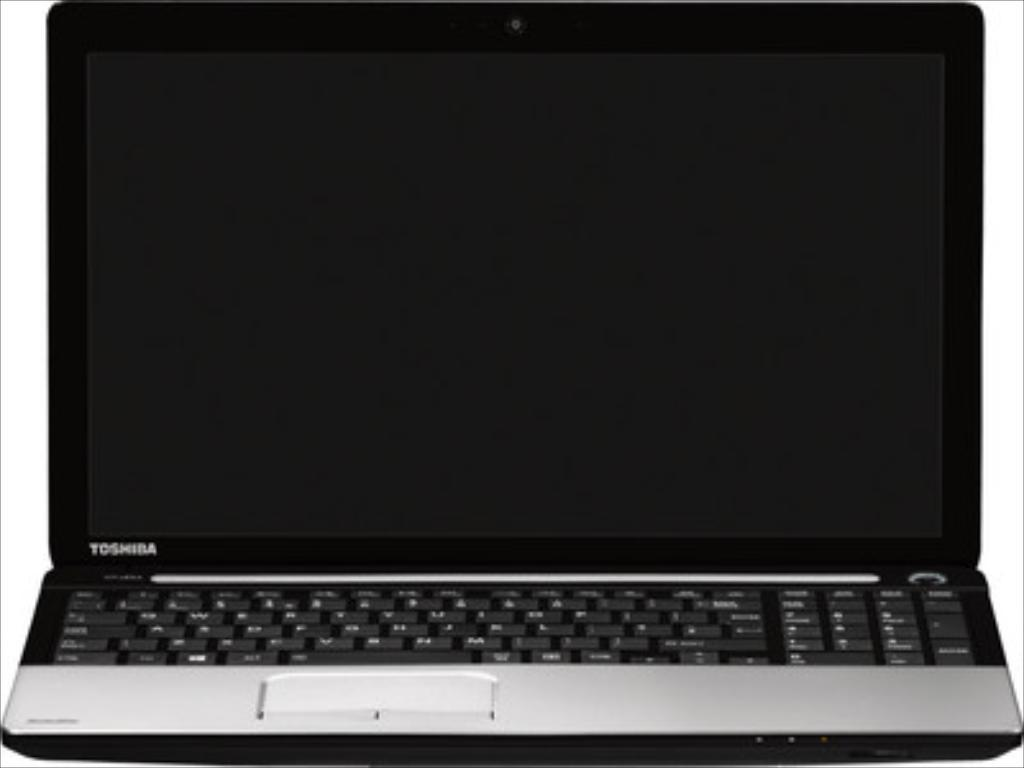Provide a one-sentence caption for the provided image. A Toshiba brand laptop sits with its cover open. 